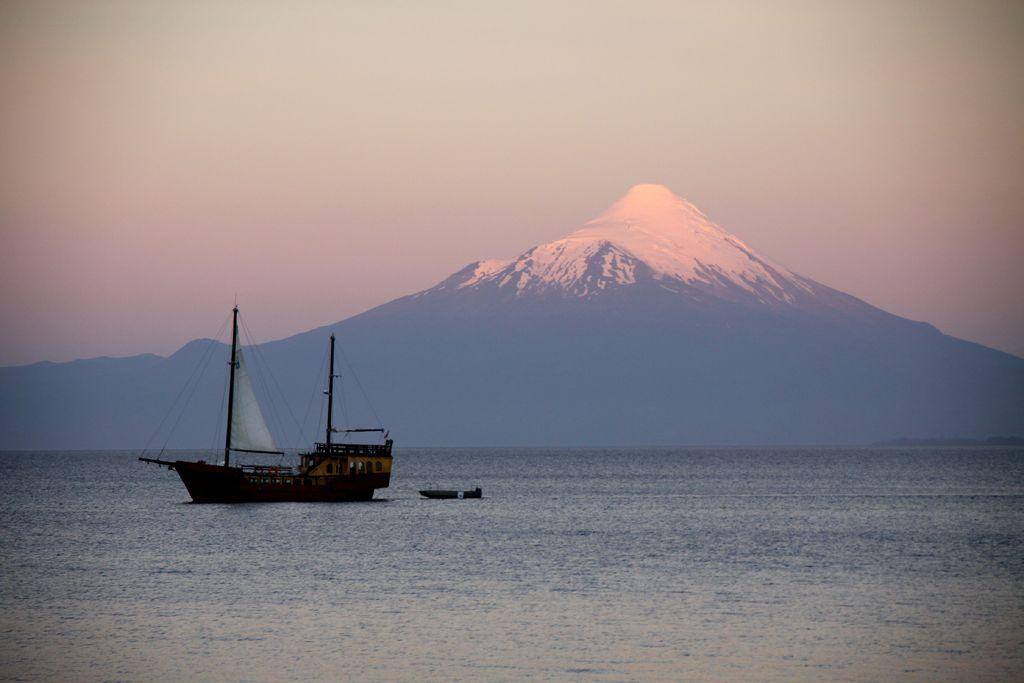How many boats can be seen in the image? There are two boats in the image. What is the location of the boats in the image? The boats are on the water. What is visible in the background of the image? There is a mountain visible behind the boats. What is visible at the top of the image? The sky is visible at the top of the image. What is the smell of the water in the image? The image does not provide any information about the smell of the water, as it is a visual medium. 